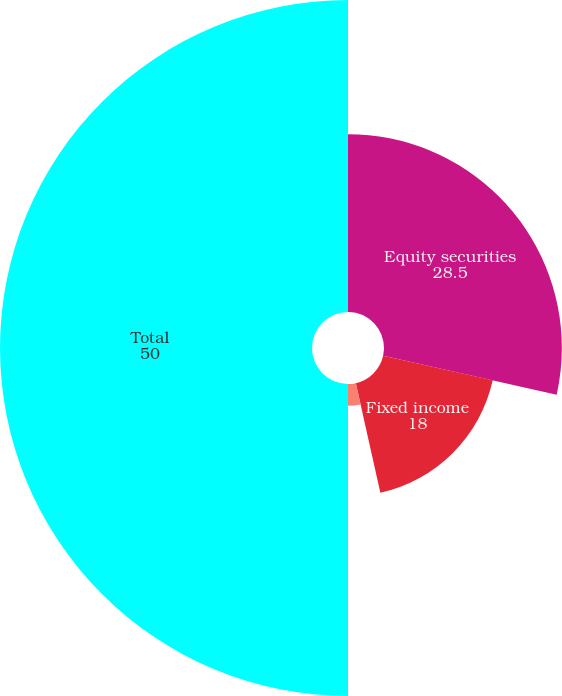<chart> <loc_0><loc_0><loc_500><loc_500><pie_chart><fcel>Equity securities<fcel>Fixed income<fcel>Real estate and other<fcel>Total<nl><fcel>28.5%<fcel>18.0%<fcel>3.5%<fcel>50.0%<nl></chart> 